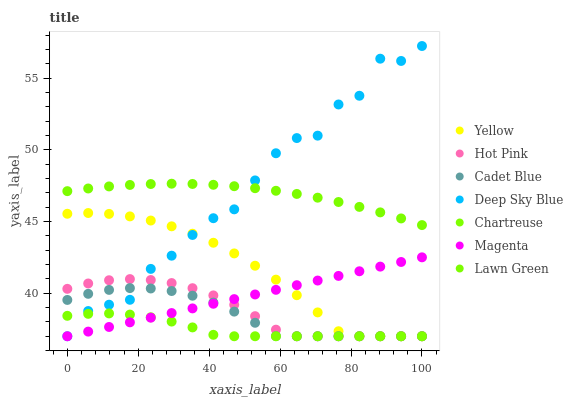Does Chartreuse have the minimum area under the curve?
Answer yes or no. Yes. Does Deep Sky Blue have the maximum area under the curve?
Answer yes or no. Yes. Does Cadet Blue have the minimum area under the curve?
Answer yes or no. No. Does Cadet Blue have the maximum area under the curve?
Answer yes or no. No. Is Magenta the smoothest?
Answer yes or no. Yes. Is Deep Sky Blue the roughest?
Answer yes or no. Yes. Is Cadet Blue the smoothest?
Answer yes or no. No. Is Cadet Blue the roughest?
Answer yes or no. No. Does Cadet Blue have the lowest value?
Answer yes or no. Yes. Does Deep Sky Blue have the highest value?
Answer yes or no. Yes. Does Cadet Blue have the highest value?
Answer yes or no. No. Is Hot Pink less than Lawn Green?
Answer yes or no. Yes. Is Lawn Green greater than Cadet Blue?
Answer yes or no. Yes. Does Cadet Blue intersect Hot Pink?
Answer yes or no. Yes. Is Cadet Blue less than Hot Pink?
Answer yes or no. No. Is Cadet Blue greater than Hot Pink?
Answer yes or no. No. Does Hot Pink intersect Lawn Green?
Answer yes or no. No. 